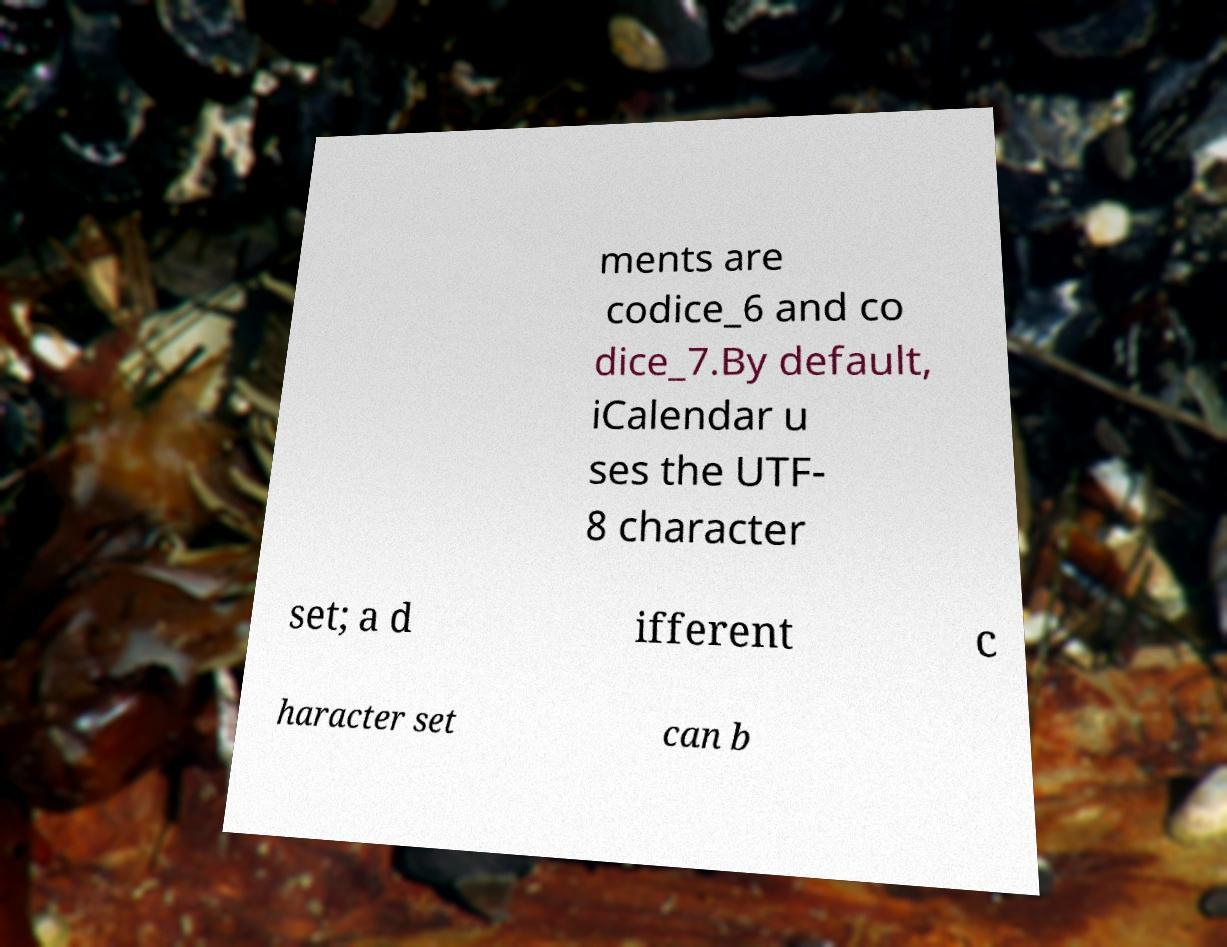Please identify and transcribe the text found in this image. ments are codice_6 and co dice_7.By default, iCalendar u ses the UTF- 8 character set; a d ifferent c haracter set can b 